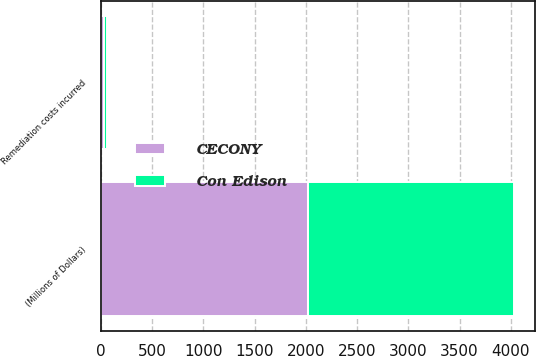Convert chart to OTSL. <chart><loc_0><loc_0><loc_500><loc_500><stacked_bar_chart><ecel><fcel>(Millions of Dollars)<fcel>Remediation costs incurred<nl><fcel>CECONY<fcel>2016<fcel>34<nl><fcel>Con Edison<fcel>2016<fcel>21<nl></chart> 